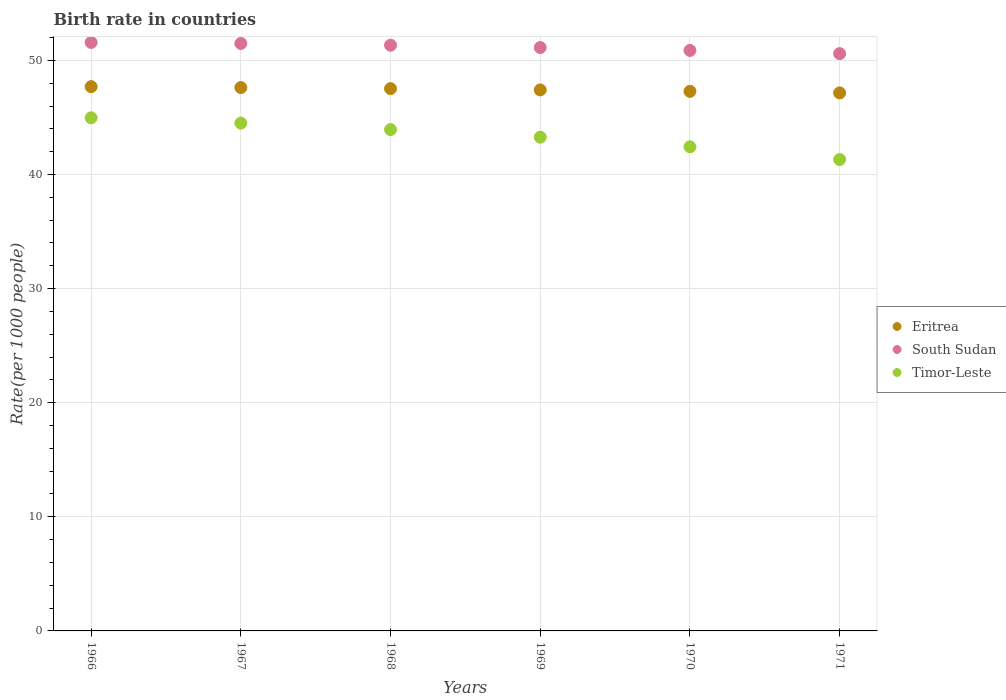What is the birth rate in Timor-Leste in 1969?
Your answer should be compact. 43.27. Across all years, what is the maximum birth rate in Timor-Leste?
Your answer should be very brief. 44.97. Across all years, what is the minimum birth rate in Eritrea?
Your response must be concise. 47.15. In which year was the birth rate in South Sudan maximum?
Offer a very short reply. 1966. What is the total birth rate in Timor-Leste in the graph?
Offer a terse response. 260.42. What is the difference between the birth rate in South Sudan in 1968 and that in 1969?
Your response must be concise. 0.21. What is the difference between the birth rate in Timor-Leste in 1969 and the birth rate in Eritrea in 1971?
Your answer should be compact. -3.88. What is the average birth rate in South Sudan per year?
Ensure brevity in your answer.  51.16. In the year 1969, what is the difference between the birth rate in South Sudan and birth rate in Timor-Leste?
Provide a short and direct response. 7.85. In how many years, is the birth rate in South Sudan greater than 14?
Make the answer very short. 6. What is the ratio of the birth rate in South Sudan in 1968 to that in 1970?
Provide a short and direct response. 1.01. Is the difference between the birth rate in South Sudan in 1966 and 1970 greater than the difference between the birth rate in Timor-Leste in 1966 and 1970?
Your response must be concise. No. What is the difference between the highest and the second highest birth rate in Timor-Leste?
Keep it short and to the point. 0.47. What is the difference between the highest and the lowest birth rate in Eritrea?
Keep it short and to the point. 0.55. Is the sum of the birth rate in South Sudan in 1966 and 1969 greater than the maximum birth rate in Eritrea across all years?
Give a very brief answer. Yes. Is it the case that in every year, the sum of the birth rate in Timor-Leste and birth rate in Eritrea  is greater than the birth rate in South Sudan?
Ensure brevity in your answer.  Yes. Is the birth rate in South Sudan strictly less than the birth rate in Timor-Leste over the years?
Make the answer very short. No. How many dotlines are there?
Offer a terse response. 3. What is the difference between two consecutive major ticks on the Y-axis?
Your answer should be compact. 10. How are the legend labels stacked?
Ensure brevity in your answer.  Vertical. What is the title of the graph?
Your answer should be very brief. Birth rate in countries. What is the label or title of the Y-axis?
Keep it short and to the point. Rate(per 1000 people). What is the Rate(per 1000 people) in Eritrea in 1966?
Keep it short and to the point. 47.7. What is the Rate(per 1000 people) in South Sudan in 1966?
Your response must be concise. 51.57. What is the Rate(per 1000 people) of Timor-Leste in 1966?
Ensure brevity in your answer.  44.97. What is the Rate(per 1000 people) in Eritrea in 1967?
Give a very brief answer. 47.62. What is the Rate(per 1000 people) in South Sudan in 1967?
Ensure brevity in your answer.  51.48. What is the Rate(per 1000 people) in Timor-Leste in 1967?
Provide a succinct answer. 44.5. What is the Rate(per 1000 people) in Eritrea in 1968?
Ensure brevity in your answer.  47.52. What is the Rate(per 1000 people) in South Sudan in 1968?
Provide a succinct answer. 51.33. What is the Rate(per 1000 people) in Timor-Leste in 1968?
Make the answer very short. 43.94. What is the Rate(per 1000 people) in Eritrea in 1969?
Give a very brief answer. 47.41. What is the Rate(per 1000 people) in South Sudan in 1969?
Your answer should be compact. 51.12. What is the Rate(per 1000 people) of Timor-Leste in 1969?
Make the answer very short. 43.27. What is the Rate(per 1000 people) of Eritrea in 1970?
Provide a succinct answer. 47.29. What is the Rate(per 1000 people) of South Sudan in 1970?
Give a very brief answer. 50.87. What is the Rate(per 1000 people) in Timor-Leste in 1970?
Offer a terse response. 42.43. What is the Rate(per 1000 people) of Eritrea in 1971?
Your answer should be very brief. 47.15. What is the Rate(per 1000 people) of South Sudan in 1971?
Ensure brevity in your answer.  50.59. What is the Rate(per 1000 people) in Timor-Leste in 1971?
Give a very brief answer. 41.31. Across all years, what is the maximum Rate(per 1000 people) in Eritrea?
Your answer should be very brief. 47.7. Across all years, what is the maximum Rate(per 1000 people) of South Sudan?
Make the answer very short. 51.57. Across all years, what is the maximum Rate(per 1000 people) in Timor-Leste?
Provide a short and direct response. 44.97. Across all years, what is the minimum Rate(per 1000 people) in Eritrea?
Your answer should be very brief. 47.15. Across all years, what is the minimum Rate(per 1000 people) in South Sudan?
Offer a terse response. 50.59. Across all years, what is the minimum Rate(per 1000 people) of Timor-Leste?
Keep it short and to the point. 41.31. What is the total Rate(per 1000 people) in Eritrea in the graph?
Make the answer very short. 284.7. What is the total Rate(per 1000 people) of South Sudan in the graph?
Ensure brevity in your answer.  306.98. What is the total Rate(per 1000 people) of Timor-Leste in the graph?
Your answer should be very brief. 260.42. What is the difference between the Rate(per 1000 people) of Eritrea in 1966 and that in 1967?
Provide a succinct answer. 0.08. What is the difference between the Rate(per 1000 people) in South Sudan in 1966 and that in 1967?
Provide a short and direct response. 0.09. What is the difference between the Rate(per 1000 people) of Timor-Leste in 1966 and that in 1967?
Give a very brief answer. 0.47. What is the difference between the Rate(per 1000 people) in Eritrea in 1966 and that in 1968?
Offer a very short reply. 0.17. What is the difference between the Rate(per 1000 people) of South Sudan in 1966 and that in 1968?
Your response must be concise. 0.24. What is the difference between the Rate(per 1000 people) in Timor-Leste in 1966 and that in 1968?
Your response must be concise. 1.03. What is the difference between the Rate(per 1000 people) of Eritrea in 1966 and that in 1969?
Offer a terse response. 0.29. What is the difference between the Rate(per 1000 people) of South Sudan in 1966 and that in 1969?
Ensure brevity in your answer.  0.45. What is the difference between the Rate(per 1000 people) in Timor-Leste in 1966 and that in 1969?
Give a very brief answer. 1.7. What is the difference between the Rate(per 1000 people) in Eritrea in 1966 and that in 1970?
Ensure brevity in your answer.  0.41. What is the difference between the Rate(per 1000 people) of South Sudan in 1966 and that in 1970?
Provide a succinct answer. 0.7. What is the difference between the Rate(per 1000 people) of Timor-Leste in 1966 and that in 1970?
Make the answer very short. 2.54. What is the difference between the Rate(per 1000 people) of Eritrea in 1966 and that in 1971?
Provide a short and direct response. 0.55. What is the difference between the Rate(per 1000 people) of South Sudan in 1966 and that in 1971?
Keep it short and to the point. 0.98. What is the difference between the Rate(per 1000 people) in Timor-Leste in 1966 and that in 1971?
Offer a terse response. 3.65. What is the difference between the Rate(per 1000 people) in Eritrea in 1967 and that in 1968?
Make the answer very short. 0.1. What is the difference between the Rate(per 1000 people) of South Sudan in 1967 and that in 1968?
Provide a succinct answer. 0.15. What is the difference between the Rate(per 1000 people) of Timor-Leste in 1967 and that in 1968?
Keep it short and to the point. 0.56. What is the difference between the Rate(per 1000 people) of Eritrea in 1967 and that in 1969?
Offer a terse response. 0.21. What is the difference between the Rate(per 1000 people) in South Sudan in 1967 and that in 1969?
Ensure brevity in your answer.  0.36. What is the difference between the Rate(per 1000 people) of Timor-Leste in 1967 and that in 1969?
Keep it short and to the point. 1.23. What is the difference between the Rate(per 1000 people) of Eritrea in 1967 and that in 1970?
Offer a very short reply. 0.33. What is the difference between the Rate(per 1000 people) of South Sudan in 1967 and that in 1970?
Your answer should be compact. 0.61. What is the difference between the Rate(per 1000 people) of Timor-Leste in 1967 and that in 1970?
Provide a succinct answer. 2.08. What is the difference between the Rate(per 1000 people) in Eritrea in 1967 and that in 1971?
Your answer should be very brief. 0.47. What is the difference between the Rate(per 1000 people) of South Sudan in 1967 and that in 1971?
Offer a very short reply. 0.89. What is the difference between the Rate(per 1000 people) of Timor-Leste in 1967 and that in 1971?
Your answer should be very brief. 3.19. What is the difference between the Rate(per 1000 people) in Eritrea in 1968 and that in 1969?
Offer a very short reply. 0.11. What is the difference between the Rate(per 1000 people) in South Sudan in 1968 and that in 1969?
Ensure brevity in your answer.  0.21. What is the difference between the Rate(per 1000 people) in Timor-Leste in 1968 and that in 1969?
Keep it short and to the point. 0.67. What is the difference between the Rate(per 1000 people) of Eritrea in 1968 and that in 1970?
Your answer should be compact. 0.24. What is the difference between the Rate(per 1000 people) in South Sudan in 1968 and that in 1970?
Keep it short and to the point. 0.46. What is the difference between the Rate(per 1000 people) of Timor-Leste in 1968 and that in 1970?
Give a very brief answer. 1.51. What is the difference between the Rate(per 1000 people) of Eritrea in 1968 and that in 1971?
Your answer should be compact. 0.37. What is the difference between the Rate(per 1000 people) in South Sudan in 1968 and that in 1971?
Your answer should be very brief. 0.74. What is the difference between the Rate(per 1000 people) of Timor-Leste in 1968 and that in 1971?
Provide a succinct answer. 2.62. What is the difference between the Rate(per 1000 people) of Eritrea in 1969 and that in 1970?
Your response must be concise. 0.13. What is the difference between the Rate(per 1000 people) in South Sudan in 1969 and that in 1970?
Your answer should be compact. 0.25. What is the difference between the Rate(per 1000 people) in Timor-Leste in 1969 and that in 1970?
Your answer should be compact. 0.84. What is the difference between the Rate(per 1000 people) of Eritrea in 1969 and that in 1971?
Offer a terse response. 0.26. What is the difference between the Rate(per 1000 people) in South Sudan in 1969 and that in 1971?
Provide a succinct answer. 0.53. What is the difference between the Rate(per 1000 people) of Timor-Leste in 1969 and that in 1971?
Give a very brief answer. 1.96. What is the difference between the Rate(per 1000 people) in Eritrea in 1970 and that in 1971?
Provide a short and direct response. 0.14. What is the difference between the Rate(per 1000 people) in South Sudan in 1970 and that in 1971?
Offer a very short reply. 0.28. What is the difference between the Rate(per 1000 people) in Timor-Leste in 1970 and that in 1971?
Your answer should be compact. 1.11. What is the difference between the Rate(per 1000 people) in Eritrea in 1966 and the Rate(per 1000 people) in South Sudan in 1967?
Make the answer very short. -3.78. What is the difference between the Rate(per 1000 people) in Eritrea in 1966 and the Rate(per 1000 people) in Timor-Leste in 1967?
Ensure brevity in your answer.  3.2. What is the difference between the Rate(per 1000 people) of South Sudan in 1966 and the Rate(per 1000 people) of Timor-Leste in 1967?
Your response must be concise. 7.07. What is the difference between the Rate(per 1000 people) of Eritrea in 1966 and the Rate(per 1000 people) of South Sudan in 1968?
Offer a very short reply. -3.63. What is the difference between the Rate(per 1000 people) of Eritrea in 1966 and the Rate(per 1000 people) of Timor-Leste in 1968?
Give a very brief answer. 3.76. What is the difference between the Rate(per 1000 people) of South Sudan in 1966 and the Rate(per 1000 people) of Timor-Leste in 1968?
Keep it short and to the point. 7.64. What is the difference between the Rate(per 1000 people) of Eritrea in 1966 and the Rate(per 1000 people) of South Sudan in 1969?
Keep it short and to the point. -3.42. What is the difference between the Rate(per 1000 people) in Eritrea in 1966 and the Rate(per 1000 people) in Timor-Leste in 1969?
Give a very brief answer. 4.43. What is the difference between the Rate(per 1000 people) in South Sudan in 1966 and the Rate(per 1000 people) in Timor-Leste in 1969?
Provide a short and direct response. 8.3. What is the difference between the Rate(per 1000 people) of Eritrea in 1966 and the Rate(per 1000 people) of South Sudan in 1970?
Offer a very short reply. -3.17. What is the difference between the Rate(per 1000 people) in Eritrea in 1966 and the Rate(per 1000 people) in Timor-Leste in 1970?
Give a very brief answer. 5.27. What is the difference between the Rate(per 1000 people) of South Sudan in 1966 and the Rate(per 1000 people) of Timor-Leste in 1970?
Give a very brief answer. 9.15. What is the difference between the Rate(per 1000 people) in Eritrea in 1966 and the Rate(per 1000 people) in South Sudan in 1971?
Keep it short and to the point. -2.89. What is the difference between the Rate(per 1000 people) of Eritrea in 1966 and the Rate(per 1000 people) of Timor-Leste in 1971?
Keep it short and to the point. 6.38. What is the difference between the Rate(per 1000 people) of South Sudan in 1966 and the Rate(per 1000 people) of Timor-Leste in 1971?
Ensure brevity in your answer.  10.26. What is the difference between the Rate(per 1000 people) of Eritrea in 1967 and the Rate(per 1000 people) of South Sudan in 1968?
Your response must be concise. -3.71. What is the difference between the Rate(per 1000 people) of Eritrea in 1967 and the Rate(per 1000 people) of Timor-Leste in 1968?
Ensure brevity in your answer.  3.68. What is the difference between the Rate(per 1000 people) in South Sudan in 1967 and the Rate(per 1000 people) in Timor-Leste in 1968?
Keep it short and to the point. 7.55. What is the difference between the Rate(per 1000 people) in Eritrea in 1967 and the Rate(per 1000 people) in South Sudan in 1969?
Offer a terse response. -3.5. What is the difference between the Rate(per 1000 people) of Eritrea in 1967 and the Rate(per 1000 people) of Timor-Leste in 1969?
Provide a short and direct response. 4.35. What is the difference between the Rate(per 1000 people) of South Sudan in 1967 and the Rate(per 1000 people) of Timor-Leste in 1969?
Your response must be concise. 8.21. What is the difference between the Rate(per 1000 people) in Eritrea in 1967 and the Rate(per 1000 people) in South Sudan in 1970?
Provide a short and direct response. -3.25. What is the difference between the Rate(per 1000 people) of Eritrea in 1967 and the Rate(per 1000 people) of Timor-Leste in 1970?
Make the answer very short. 5.2. What is the difference between the Rate(per 1000 people) in South Sudan in 1967 and the Rate(per 1000 people) in Timor-Leste in 1970?
Your answer should be compact. 9.06. What is the difference between the Rate(per 1000 people) in Eritrea in 1967 and the Rate(per 1000 people) in South Sudan in 1971?
Your answer should be very brief. -2.97. What is the difference between the Rate(per 1000 people) of Eritrea in 1967 and the Rate(per 1000 people) of Timor-Leste in 1971?
Provide a short and direct response. 6.31. What is the difference between the Rate(per 1000 people) in South Sudan in 1967 and the Rate(per 1000 people) in Timor-Leste in 1971?
Offer a terse response. 10.17. What is the difference between the Rate(per 1000 people) in Eritrea in 1968 and the Rate(per 1000 people) in South Sudan in 1969?
Offer a terse response. -3.6. What is the difference between the Rate(per 1000 people) in Eritrea in 1968 and the Rate(per 1000 people) in Timor-Leste in 1969?
Offer a very short reply. 4.25. What is the difference between the Rate(per 1000 people) of South Sudan in 1968 and the Rate(per 1000 people) of Timor-Leste in 1969?
Provide a succinct answer. 8.06. What is the difference between the Rate(per 1000 people) of Eritrea in 1968 and the Rate(per 1000 people) of South Sudan in 1970?
Give a very brief answer. -3.35. What is the difference between the Rate(per 1000 people) in Eritrea in 1968 and the Rate(per 1000 people) in Timor-Leste in 1970?
Offer a terse response. 5.1. What is the difference between the Rate(per 1000 people) of South Sudan in 1968 and the Rate(per 1000 people) of Timor-Leste in 1970?
Provide a succinct answer. 8.91. What is the difference between the Rate(per 1000 people) of Eritrea in 1968 and the Rate(per 1000 people) of South Sudan in 1971?
Keep it short and to the point. -3.07. What is the difference between the Rate(per 1000 people) of Eritrea in 1968 and the Rate(per 1000 people) of Timor-Leste in 1971?
Ensure brevity in your answer.  6.21. What is the difference between the Rate(per 1000 people) of South Sudan in 1968 and the Rate(per 1000 people) of Timor-Leste in 1971?
Offer a very short reply. 10.02. What is the difference between the Rate(per 1000 people) of Eritrea in 1969 and the Rate(per 1000 people) of South Sudan in 1970?
Provide a short and direct response. -3.46. What is the difference between the Rate(per 1000 people) in Eritrea in 1969 and the Rate(per 1000 people) in Timor-Leste in 1970?
Give a very brief answer. 4.99. What is the difference between the Rate(per 1000 people) of South Sudan in 1969 and the Rate(per 1000 people) of Timor-Leste in 1970?
Keep it short and to the point. 8.7. What is the difference between the Rate(per 1000 people) of Eritrea in 1969 and the Rate(per 1000 people) of South Sudan in 1971?
Offer a terse response. -3.18. What is the difference between the Rate(per 1000 people) in Eritrea in 1969 and the Rate(per 1000 people) in Timor-Leste in 1971?
Offer a terse response. 6.1. What is the difference between the Rate(per 1000 people) of South Sudan in 1969 and the Rate(per 1000 people) of Timor-Leste in 1971?
Provide a short and direct response. 9.81. What is the difference between the Rate(per 1000 people) of Eritrea in 1970 and the Rate(per 1000 people) of South Sudan in 1971?
Give a very brief answer. -3.31. What is the difference between the Rate(per 1000 people) in Eritrea in 1970 and the Rate(per 1000 people) in Timor-Leste in 1971?
Offer a terse response. 5.97. What is the difference between the Rate(per 1000 people) of South Sudan in 1970 and the Rate(per 1000 people) of Timor-Leste in 1971?
Ensure brevity in your answer.  9.56. What is the average Rate(per 1000 people) of Eritrea per year?
Provide a succinct answer. 47.45. What is the average Rate(per 1000 people) of South Sudan per year?
Offer a terse response. 51.16. What is the average Rate(per 1000 people) of Timor-Leste per year?
Make the answer very short. 43.4. In the year 1966, what is the difference between the Rate(per 1000 people) in Eritrea and Rate(per 1000 people) in South Sudan?
Provide a succinct answer. -3.87. In the year 1966, what is the difference between the Rate(per 1000 people) of Eritrea and Rate(per 1000 people) of Timor-Leste?
Your answer should be compact. 2.73. In the year 1966, what is the difference between the Rate(per 1000 people) in South Sudan and Rate(per 1000 people) in Timor-Leste?
Offer a terse response. 6.61. In the year 1967, what is the difference between the Rate(per 1000 people) of Eritrea and Rate(per 1000 people) of South Sudan?
Give a very brief answer. -3.86. In the year 1967, what is the difference between the Rate(per 1000 people) in Eritrea and Rate(per 1000 people) in Timor-Leste?
Keep it short and to the point. 3.12. In the year 1967, what is the difference between the Rate(per 1000 people) of South Sudan and Rate(per 1000 people) of Timor-Leste?
Your answer should be compact. 6.98. In the year 1968, what is the difference between the Rate(per 1000 people) in Eritrea and Rate(per 1000 people) in South Sudan?
Your answer should be compact. -3.81. In the year 1968, what is the difference between the Rate(per 1000 people) of Eritrea and Rate(per 1000 people) of Timor-Leste?
Provide a short and direct response. 3.59. In the year 1968, what is the difference between the Rate(per 1000 people) of South Sudan and Rate(per 1000 people) of Timor-Leste?
Ensure brevity in your answer.  7.39. In the year 1969, what is the difference between the Rate(per 1000 people) of Eritrea and Rate(per 1000 people) of South Sudan?
Provide a short and direct response. -3.71. In the year 1969, what is the difference between the Rate(per 1000 people) of Eritrea and Rate(per 1000 people) of Timor-Leste?
Ensure brevity in your answer.  4.14. In the year 1969, what is the difference between the Rate(per 1000 people) in South Sudan and Rate(per 1000 people) in Timor-Leste?
Offer a very short reply. 7.86. In the year 1970, what is the difference between the Rate(per 1000 people) of Eritrea and Rate(per 1000 people) of South Sudan?
Your answer should be compact. -3.59. In the year 1970, what is the difference between the Rate(per 1000 people) of Eritrea and Rate(per 1000 people) of Timor-Leste?
Your response must be concise. 4.86. In the year 1970, what is the difference between the Rate(per 1000 people) in South Sudan and Rate(per 1000 people) in Timor-Leste?
Give a very brief answer. 8.45. In the year 1971, what is the difference between the Rate(per 1000 people) in Eritrea and Rate(per 1000 people) in South Sudan?
Your answer should be compact. -3.44. In the year 1971, what is the difference between the Rate(per 1000 people) of Eritrea and Rate(per 1000 people) of Timor-Leste?
Provide a succinct answer. 5.84. In the year 1971, what is the difference between the Rate(per 1000 people) in South Sudan and Rate(per 1000 people) in Timor-Leste?
Keep it short and to the point. 9.28. What is the ratio of the Rate(per 1000 people) in Eritrea in 1966 to that in 1967?
Your response must be concise. 1. What is the ratio of the Rate(per 1000 people) of Timor-Leste in 1966 to that in 1967?
Keep it short and to the point. 1.01. What is the ratio of the Rate(per 1000 people) of Eritrea in 1966 to that in 1968?
Your answer should be compact. 1. What is the ratio of the Rate(per 1000 people) in South Sudan in 1966 to that in 1968?
Provide a short and direct response. 1. What is the ratio of the Rate(per 1000 people) of Timor-Leste in 1966 to that in 1968?
Make the answer very short. 1.02. What is the ratio of the Rate(per 1000 people) of South Sudan in 1966 to that in 1969?
Provide a succinct answer. 1.01. What is the ratio of the Rate(per 1000 people) in Timor-Leste in 1966 to that in 1969?
Your answer should be compact. 1.04. What is the ratio of the Rate(per 1000 people) of Eritrea in 1966 to that in 1970?
Your answer should be very brief. 1.01. What is the ratio of the Rate(per 1000 people) in South Sudan in 1966 to that in 1970?
Provide a succinct answer. 1.01. What is the ratio of the Rate(per 1000 people) in Timor-Leste in 1966 to that in 1970?
Provide a short and direct response. 1.06. What is the ratio of the Rate(per 1000 people) in Eritrea in 1966 to that in 1971?
Your answer should be very brief. 1.01. What is the ratio of the Rate(per 1000 people) of South Sudan in 1966 to that in 1971?
Your response must be concise. 1.02. What is the ratio of the Rate(per 1000 people) in Timor-Leste in 1966 to that in 1971?
Offer a very short reply. 1.09. What is the ratio of the Rate(per 1000 people) in Eritrea in 1967 to that in 1968?
Keep it short and to the point. 1. What is the ratio of the Rate(per 1000 people) of South Sudan in 1967 to that in 1968?
Offer a terse response. 1. What is the ratio of the Rate(per 1000 people) in Timor-Leste in 1967 to that in 1968?
Ensure brevity in your answer.  1.01. What is the ratio of the Rate(per 1000 people) in Timor-Leste in 1967 to that in 1969?
Keep it short and to the point. 1.03. What is the ratio of the Rate(per 1000 people) in Eritrea in 1967 to that in 1970?
Offer a terse response. 1.01. What is the ratio of the Rate(per 1000 people) of South Sudan in 1967 to that in 1970?
Make the answer very short. 1.01. What is the ratio of the Rate(per 1000 people) of Timor-Leste in 1967 to that in 1970?
Make the answer very short. 1.05. What is the ratio of the Rate(per 1000 people) in Eritrea in 1967 to that in 1971?
Offer a very short reply. 1.01. What is the ratio of the Rate(per 1000 people) in South Sudan in 1967 to that in 1971?
Offer a very short reply. 1.02. What is the ratio of the Rate(per 1000 people) of Timor-Leste in 1967 to that in 1971?
Make the answer very short. 1.08. What is the ratio of the Rate(per 1000 people) in Timor-Leste in 1968 to that in 1969?
Make the answer very short. 1.02. What is the ratio of the Rate(per 1000 people) of Timor-Leste in 1968 to that in 1970?
Your response must be concise. 1.04. What is the ratio of the Rate(per 1000 people) of Eritrea in 1968 to that in 1971?
Offer a terse response. 1.01. What is the ratio of the Rate(per 1000 people) of South Sudan in 1968 to that in 1971?
Your answer should be very brief. 1.01. What is the ratio of the Rate(per 1000 people) of Timor-Leste in 1968 to that in 1971?
Your response must be concise. 1.06. What is the ratio of the Rate(per 1000 people) in Eritrea in 1969 to that in 1970?
Ensure brevity in your answer.  1. What is the ratio of the Rate(per 1000 people) in Timor-Leste in 1969 to that in 1970?
Your answer should be very brief. 1.02. What is the ratio of the Rate(per 1000 people) in South Sudan in 1969 to that in 1971?
Provide a short and direct response. 1.01. What is the ratio of the Rate(per 1000 people) of Timor-Leste in 1969 to that in 1971?
Provide a short and direct response. 1.05. What is the ratio of the Rate(per 1000 people) in Eritrea in 1970 to that in 1971?
Ensure brevity in your answer.  1. What is the ratio of the Rate(per 1000 people) of South Sudan in 1970 to that in 1971?
Provide a succinct answer. 1.01. What is the ratio of the Rate(per 1000 people) in Timor-Leste in 1970 to that in 1971?
Make the answer very short. 1.03. What is the difference between the highest and the second highest Rate(per 1000 people) in Eritrea?
Offer a very short reply. 0.08. What is the difference between the highest and the second highest Rate(per 1000 people) in South Sudan?
Ensure brevity in your answer.  0.09. What is the difference between the highest and the second highest Rate(per 1000 people) in Timor-Leste?
Give a very brief answer. 0.47. What is the difference between the highest and the lowest Rate(per 1000 people) of Eritrea?
Make the answer very short. 0.55. What is the difference between the highest and the lowest Rate(per 1000 people) of South Sudan?
Provide a succinct answer. 0.98. What is the difference between the highest and the lowest Rate(per 1000 people) in Timor-Leste?
Your answer should be very brief. 3.65. 